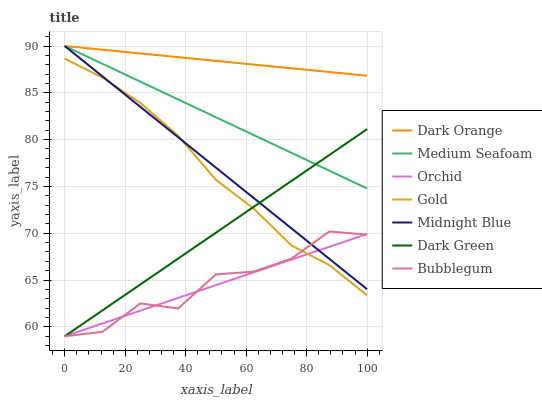Does Orchid have the minimum area under the curve?
Answer yes or no. Yes. Does Dark Orange have the maximum area under the curve?
Answer yes or no. Yes. Does Midnight Blue have the minimum area under the curve?
Answer yes or no. No. Does Midnight Blue have the maximum area under the curve?
Answer yes or no. No. Is Dark Orange the smoothest?
Answer yes or no. Yes. Is Bubblegum the roughest?
Answer yes or no. Yes. Is Midnight Blue the smoothest?
Answer yes or no. No. Is Midnight Blue the roughest?
Answer yes or no. No. Does Bubblegum have the lowest value?
Answer yes or no. Yes. Does Midnight Blue have the lowest value?
Answer yes or no. No. Does Medium Seafoam have the highest value?
Answer yes or no. Yes. Does Gold have the highest value?
Answer yes or no. No. Is Orchid less than Medium Seafoam?
Answer yes or no. Yes. Is Dark Orange greater than Dark Green?
Answer yes or no. Yes. Does Midnight Blue intersect Orchid?
Answer yes or no. Yes. Is Midnight Blue less than Orchid?
Answer yes or no. No. Is Midnight Blue greater than Orchid?
Answer yes or no. No. Does Orchid intersect Medium Seafoam?
Answer yes or no. No. 